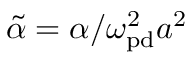<formula> <loc_0><loc_0><loc_500><loc_500>\tilde { \alpha } = \alpha / \omega _ { p d } ^ { 2 } a ^ { 2 }</formula> 